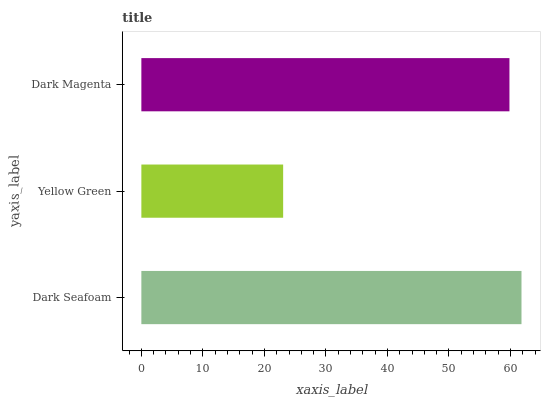Is Yellow Green the minimum?
Answer yes or no. Yes. Is Dark Seafoam the maximum?
Answer yes or no. Yes. Is Dark Magenta the minimum?
Answer yes or no. No. Is Dark Magenta the maximum?
Answer yes or no. No. Is Dark Magenta greater than Yellow Green?
Answer yes or no. Yes. Is Yellow Green less than Dark Magenta?
Answer yes or no. Yes. Is Yellow Green greater than Dark Magenta?
Answer yes or no. No. Is Dark Magenta less than Yellow Green?
Answer yes or no. No. Is Dark Magenta the high median?
Answer yes or no. Yes. Is Dark Magenta the low median?
Answer yes or no. Yes. Is Yellow Green the high median?
Answer yes or no. No. Is Dark Seafoam the low median?
Answer yes or no. No. 